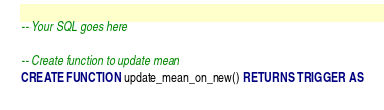<code> <loc_0><loc_0><loc_500><loc_500><_SQL_>-- Your SQL goes here

-- Create function to update mean
CREATE FUNCTION update_mean_on_new() RETURNS TRIGGER AS</code> 